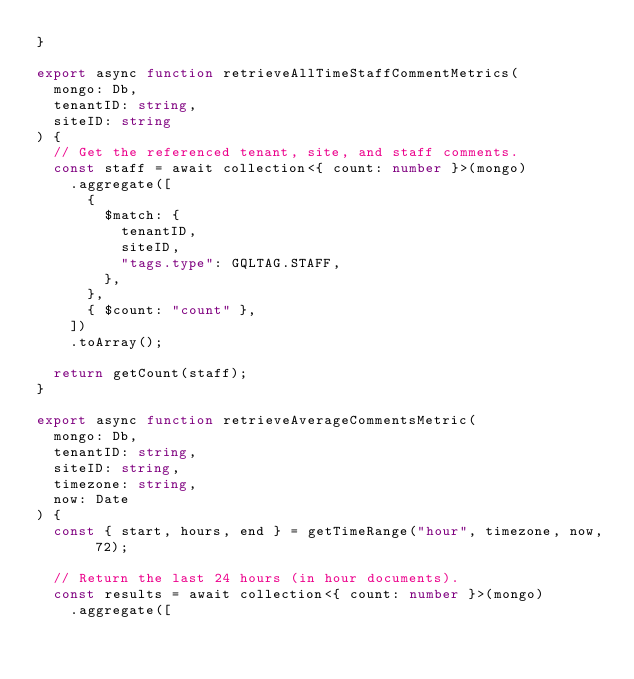<code> <loc_0><loc_0><loc_500><loc_500><_TypeScript_>}

export async function retrieveAllTimeStaffCommentMetrics(
  mongo: Db,
  tenantID: string,
  siteID: string
) {
  // Get the referenced tenant, site, and staff comments.
  const staff = await collection<{ count: number }>(mongo)
    .aggregate([
      {
        $match: {
          tenantID,
          siteID,
          "tags.type": GQLTAG.STAFF,
        },
      },
      { $count: "count" },
    ])
    .toArray();

  return getCount(staff);
}

export async function retrieveAverageCommentsMetric(
  mongo: Db,
  tenantID: string,
  siteID: string,
  timezone: string,
  now: Date
) {
  const { start, hours, end } = getTimeRange("hour", timezone, now, 72);

  // Return the last 24 hours (in hour documents).
  const results = await collection<{ count: number }>(mongo)
    .aggregate([</code> 